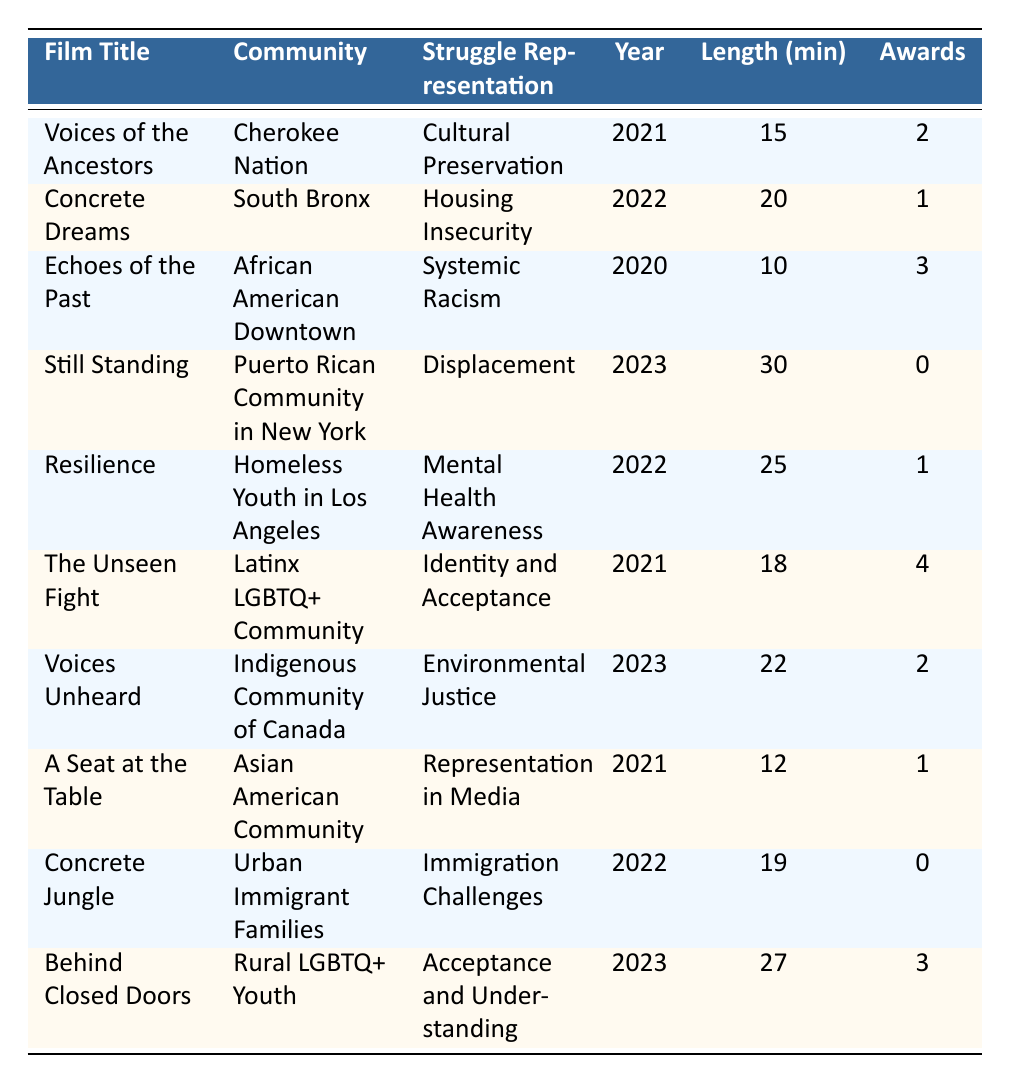What is the struggle represented in the film "Concrete Dreams"? The table shows the specific struggle representation for each film. For "Concrete Dreams," the struggle representation is listed as "Housing Insecurity."
Answer: Housing Insecurity Which film has the longest runtime, and what is its length? By examining the lengths of the films in the table, "Still Standing" has the longest runtime at 30 minutes.
Answer: Still Standing, 30 minutes How many awards did films focused on Mental Health Awareness win in total? The films related to Mental Health Awareness are "Resilience," which won 1 award. Therefore, the total number of awards is 1.
Answer: 1 Is "Voices of the Ancestors" part of the community dealing with Environmental Justice? The community represented in "Voices of the Ancestors" is the "Cherokee Nation," which is not listed under Environmental Justice; thus the statement is false.
Answer: No What is the average length of films that highlight displacement as a struggle? There is only one film, "Still Standing," that represents displacement, and its length is 30 minutes. The average is therefore 30 minutes.
Answer: 30 minutes How many awards did films released in 2021 win compared to those released in 2023? Summing the awards for films released in 2021: "Voices of the Ancestors" (2) + "The Unseen Fight" (4) + "A Seat at the Table" (1) = 7 awards. For films from 2023: "Still Standing" (0) + "Voices Unheard" (2) + "Behind Closed Doors" (3) = 5 awards. Comparing the totals: 7 awards (2021) vs. 5 awards (2023).
Answer: 7 vs. 5 Which community has the highest number of awards won in the submissions listed? By reviewing the awards column, "The Unseen Fight" wins the most with 4 awards. The Latinx LGBTQ+ Community is thus the community with the highest awards.
Answer: Latinx LGBTQ+ Community, 4 awards Did any of the films about representation receive no awards? Two films received no awards: "Still Standing" and "Concrete Jungle." Therefore, yes, there are films about representation that received no awards.
Answer: Yes In which year was the film "Echoes of the Past" released? The film "Echoes of the Past" is listed in the 2020 row of the table. Therefore, it was released in the year 2020.
Answer: 2020 